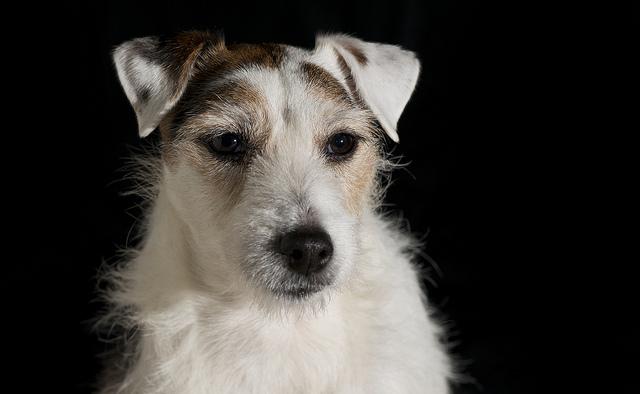Is the dog wearing a collar?
Give a very brief answer. No. Does the dog have a collar?
Keep it brief. No. How many spots do you see on the dog?
Concise answer only. 2. What is the color of the dog?
Concise answer only. White and brown. Is the dog a puppy?
Give a very brief answer. No. Is this dog pictured outside?
Quick response, please. No. 